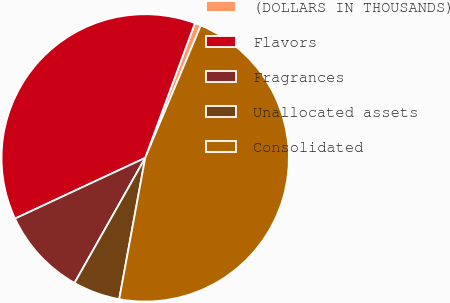<chart> <loc_0><loc_0><loc_500><loc_500><pie_chart><fcel>(DOLLARS IN THOUSANDS)<fcel>Flavors<fcel>Fragrances<fcel>Unallocated assets<fcel>Consolidated<nl><fcel>0.7%<fcel>37.57%<fcel>9.87%<fcel>5.29%<fcel>46.57%<nl></chart> 